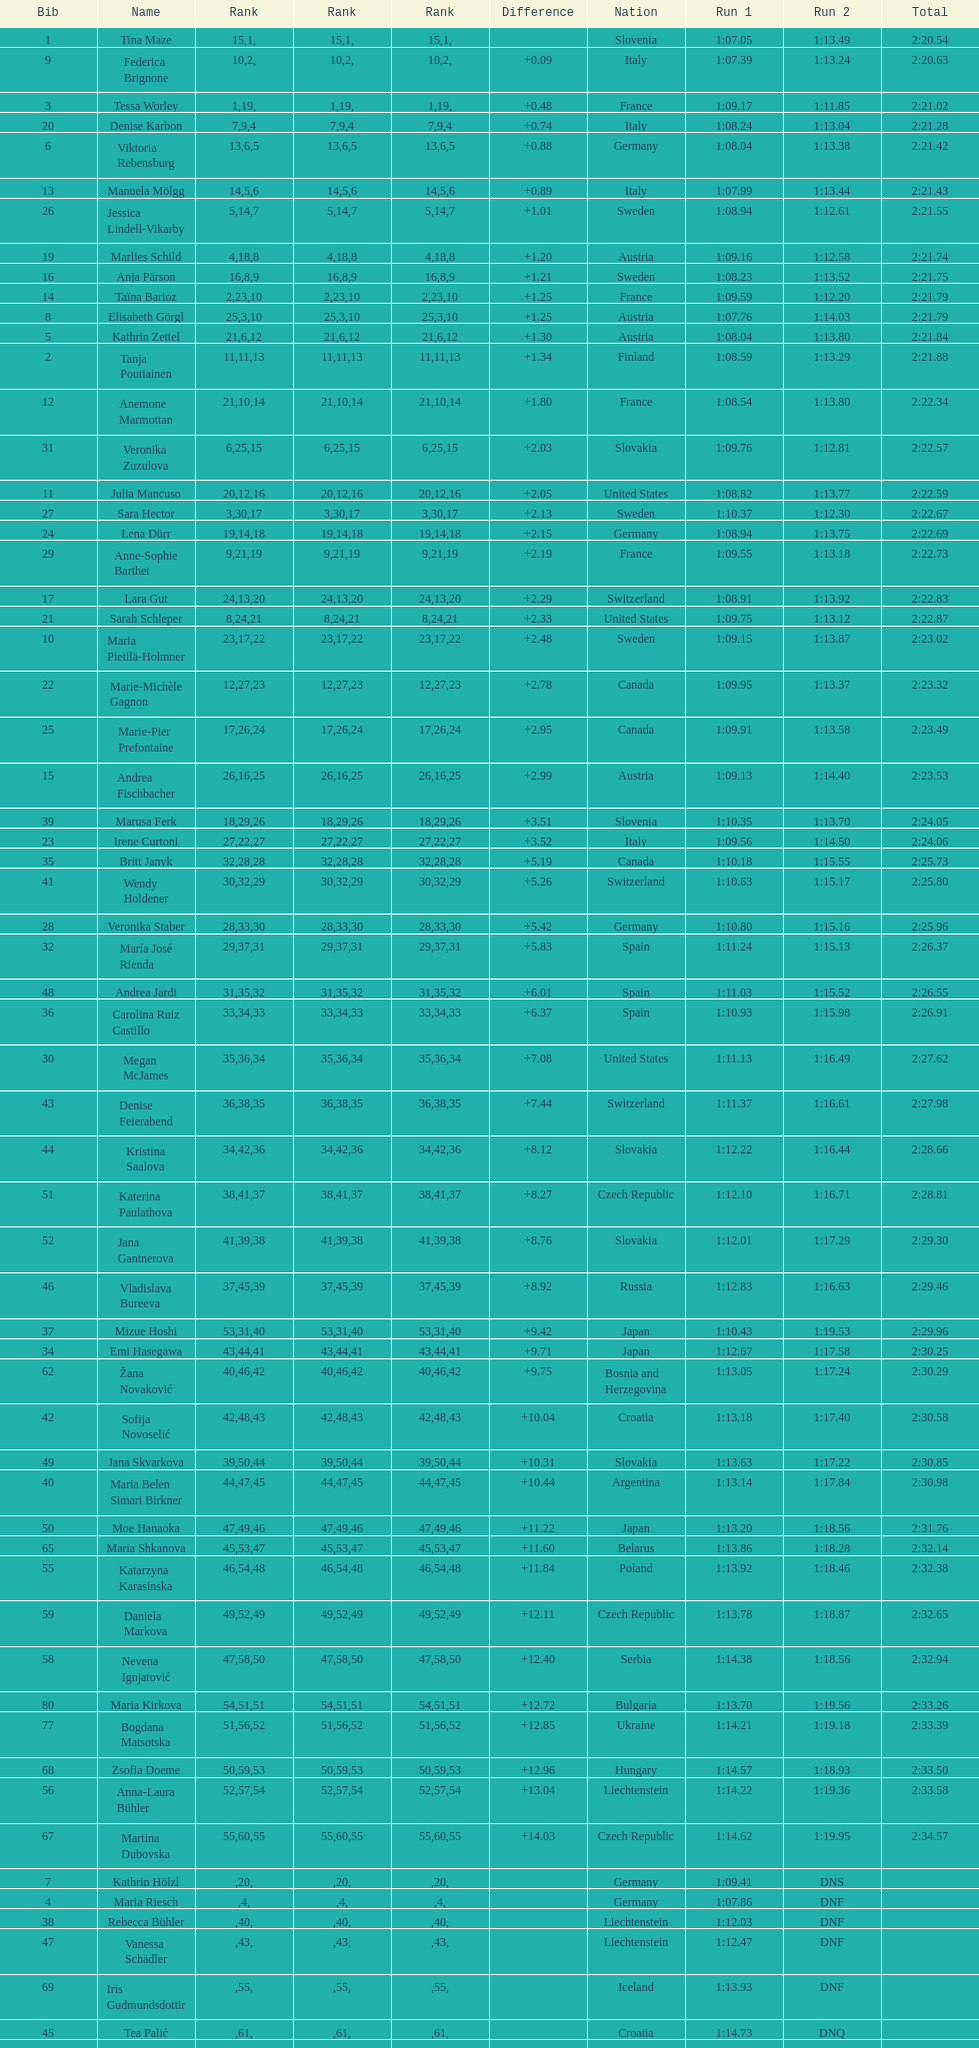Who was the last competitor to actually finish both runs? Martina Dubovska. 